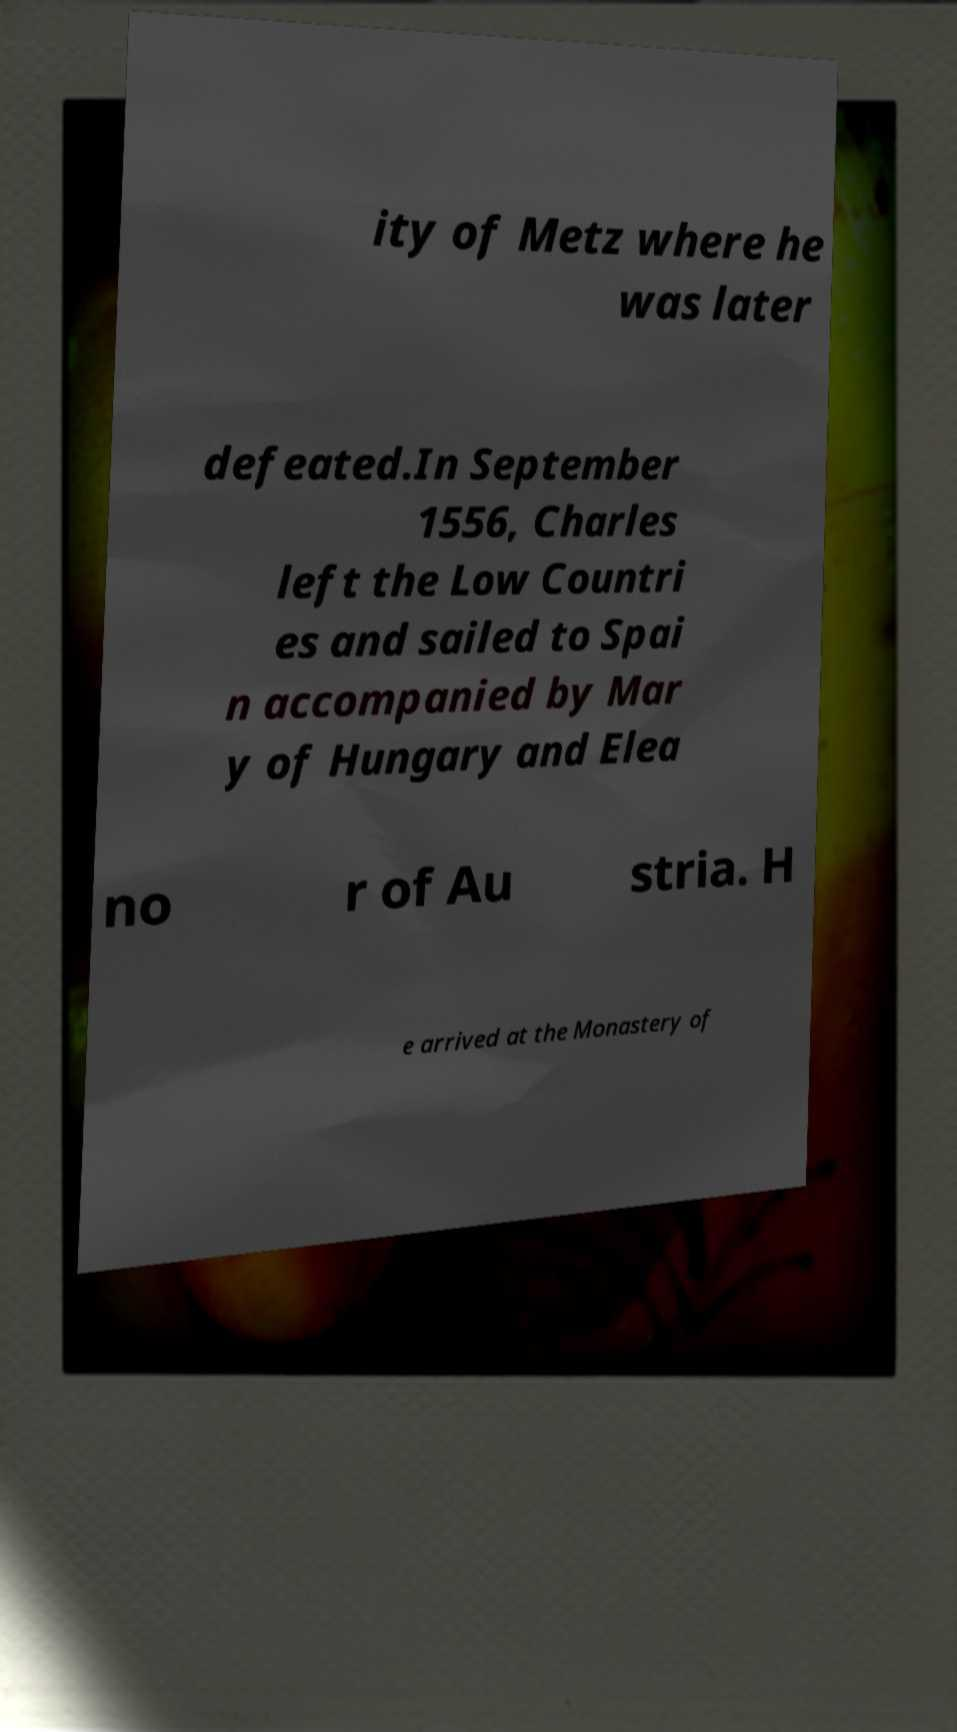Could you extract and type out the text from this image? ity of Metz where he was later defeated.In September 1556, Charles left the Low Countri es and sailed to Spai n accompanied by Mar y of Hungary and Elea no r of Au stria. H e arrived at the Monastery of 